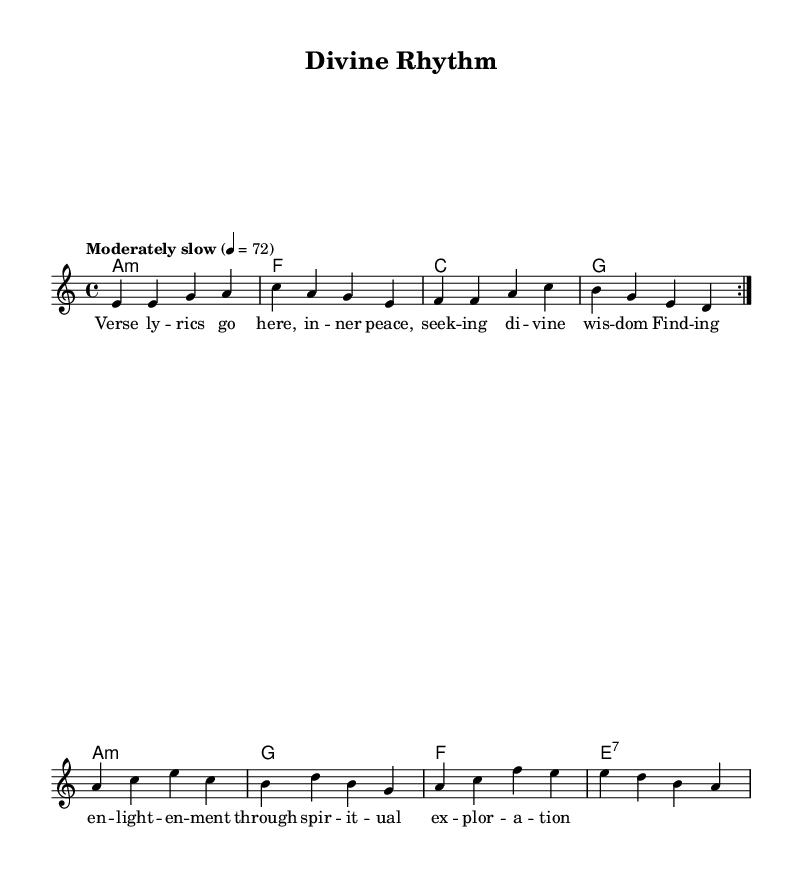What is the key signature of this music? The key signature is indicated at the beginning of the score. In this case, it shows "a minor," which has no sharps or flats.
Answer: A minor What is the time signature of this music? The time signature is displayed at the beginning of the score as "4/4," which indicates four beats per measure with a quarter note receiving one beat.
Answer: 4/4 What is the tempo marking of this music? The tempo marking is found at the beginning of the score and reads "Moderately slow", corresponding to a metronome marking of 72 beats per minute.
Answer: Moderately slow How many measures are in the melody? By counting the bars of music from the melody section, we can determine there are 8 measures present in the repeated section of the musical phrases.
Answer: 8 What chords are used in the harmony? The chord symbols listed in the harmony section include A minor, F, C, G, and E7. These chords outline the harmonic structure of the piece.
Answer: A minor, F, C, G, E7 What is the overall theme of the lyrics? The lyrics focus on inner peace and spiritual exploration, emphasizing the quest for enlightenment through divine wisdom.
Answer: Inner peace and enlightenment What is the structure of the composition? The composition follows a verse-chorus structure where specific lines are repeated (indicated by "repeat volta"), and different sections convey distinct musical ideas.
Answer: Verse-Chorus 